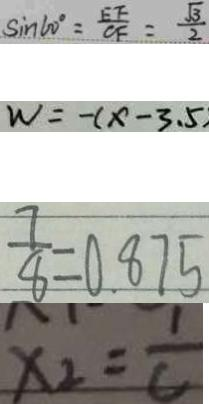<formula> <loc_0><loc_0><loc_500><loc_500>\sin 6 0 ^ { \circ } = \frac { E F } { C F } = \frac { \sqrt { 3 } } { 2 } 
 W = - ( x - 3 . 5 ) 
 \frac { 7 } { 8 } = 0 . 8 7 5 
 x _ { 2 } = \frac { 1 } { C }</formula> 